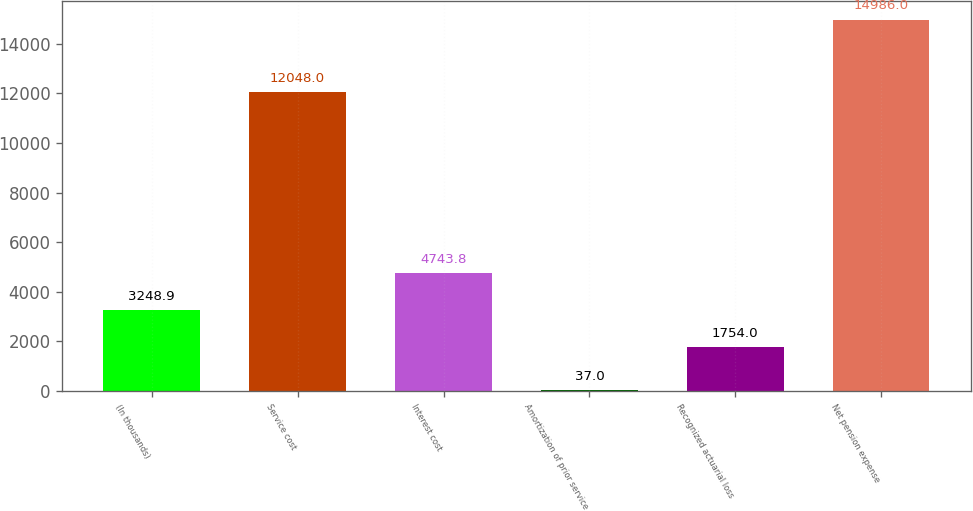Convert chart. <chart><loc_0><loc_0><loc_500><loc_500><bar_chart><fcel>(In thousands)<fcel>Service cost<fcel>Interest cost<fcel>Amortization of prior service<fcel>Recognized actuarial loss<fcel>Net pension expense<nl><fcel>3248.9<fcel>12048<fcel>4743.8<fcel>37<fcel>1754<fcel>14986<nl></chart> 